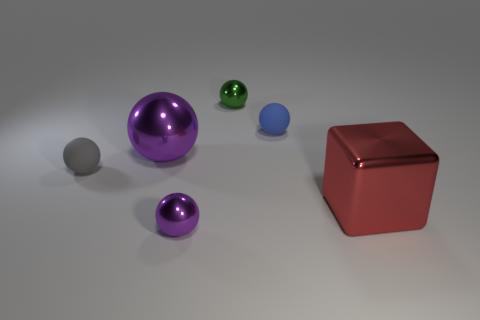Can you estimate the sizes of these objects relative to each other? While it is not possible to determine the exact sizes without additional context, we can make some relative size comparisons. The large purple ball is the biggest, followed by the red cube. The shiny object to the right of the blue sphere appears to be smaller than the green sphere but larger than the small purple sphere. The small blue sphere is the smallest visible object. 